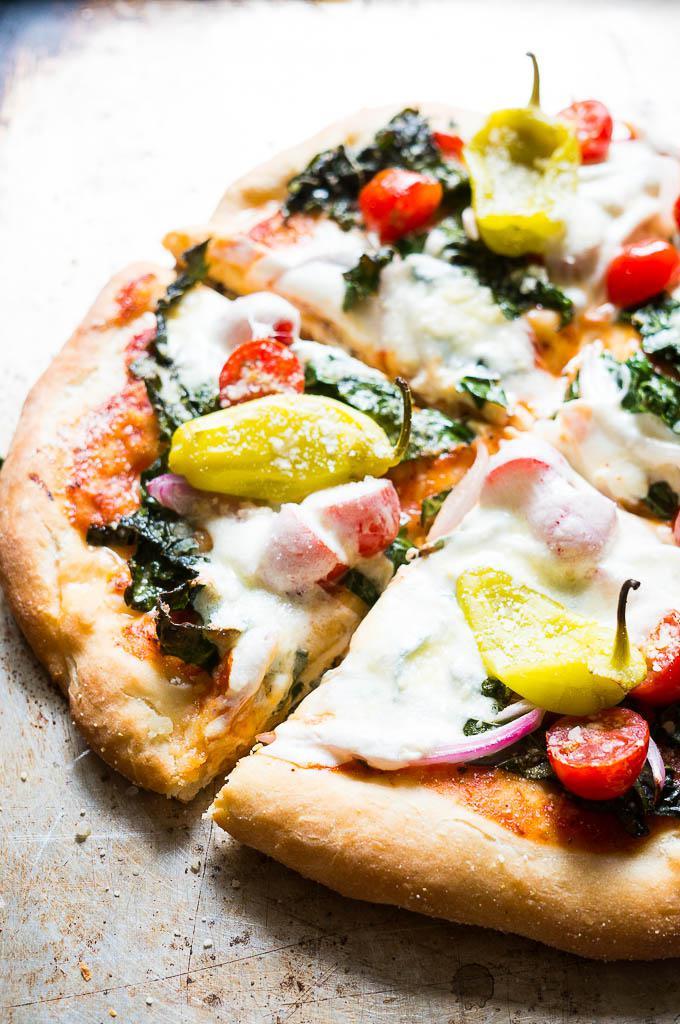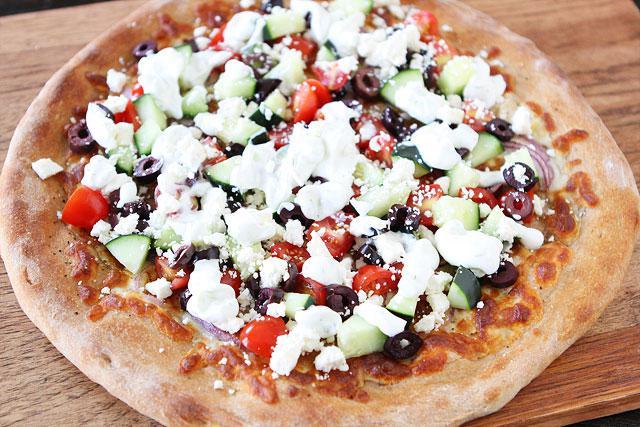The first image is the image on the left, the second image is the image on the right. Examine the images to the left and right. Is the description "The left image contains a round pizza cut in four parts, with a yellowish pepper on top of each slice." accurate? Answer yes or no. Yes. The first image is the image on the left, the second image is the image on the right. Assess this claim about the two images: "The left and right image contains the same number of circle shaped pizzas.". Correct or not? Answer yes or no. Yes. 